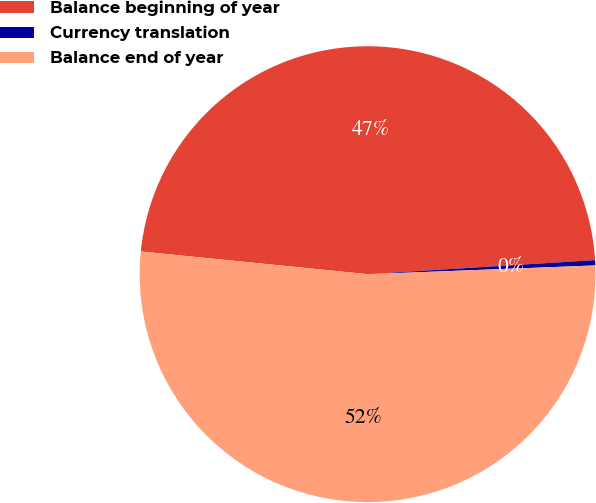Convert chart. <chart><loc_0><loc_0><loc_500><loc_500><pie_chart><fcel>Balance beginning of year<fcel>Currency translation<fcel>Balance end of year<nl><fcel>47.43%<fcel>0.37%<fcel>52.2%<nl></chart> 